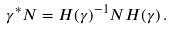Convert formula to latex. <formula><loc_0><loc_0><loc_500><loc_500>\gamma ^ { * } N = H ( \gamma ) ^ { - 1 } N H ( \gamma ) \, .</formula> 